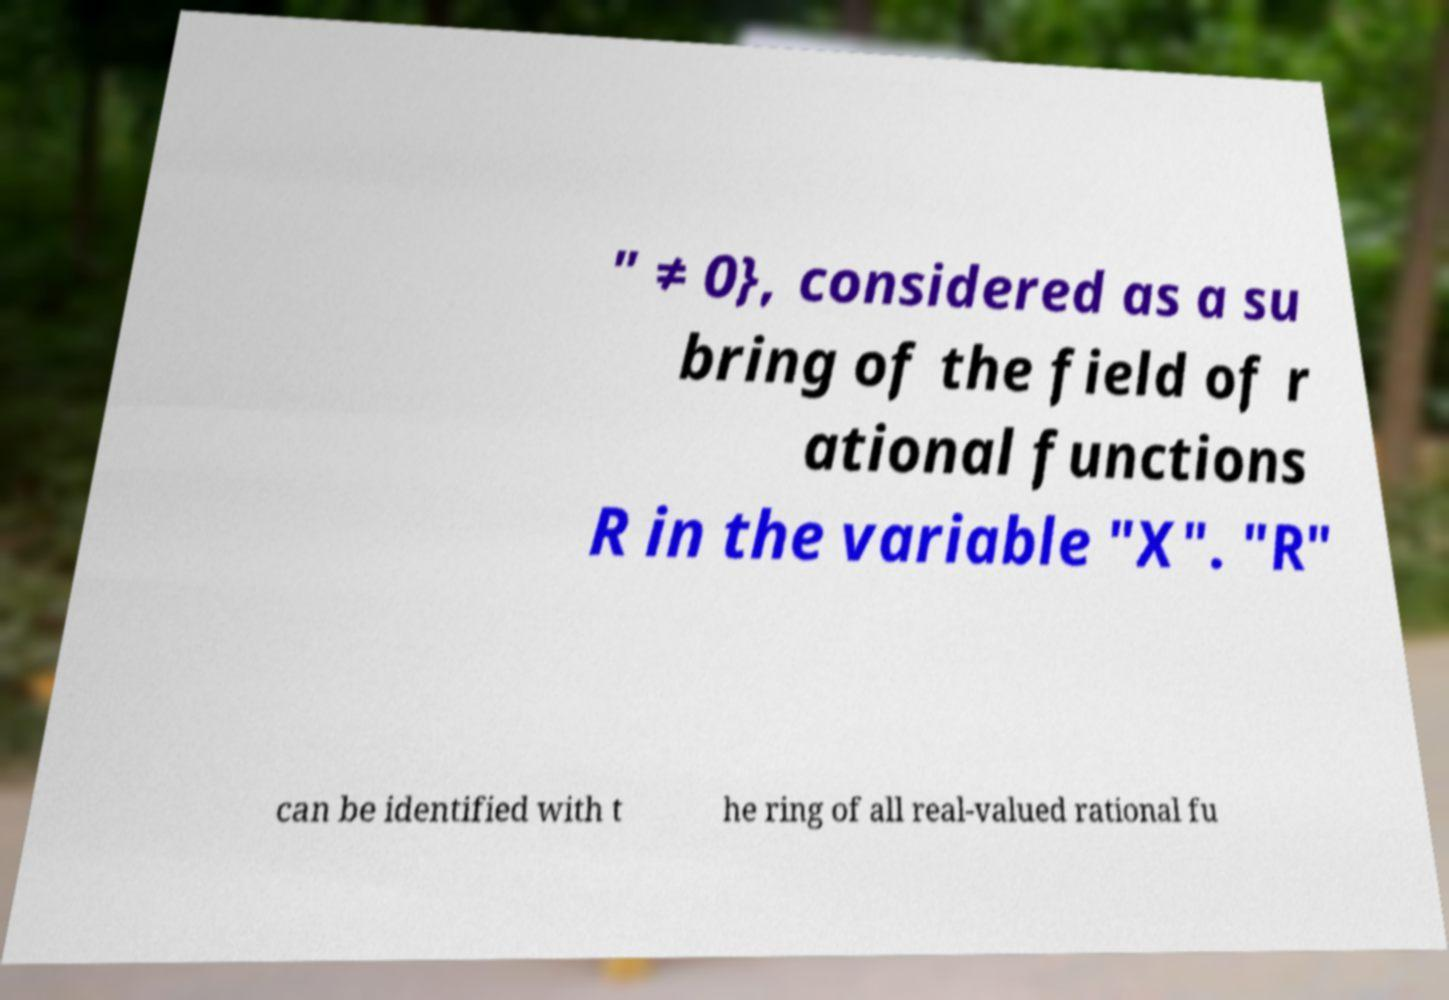Can you read and provide the text displayed in the image?This photo seems to have some interesting text. Can you extract and type it out for me? " ≠ 0}, considered as a su bring of the field of r ational functions R in the variable "X". "R" can be identified with t he ring of all real-valued rational fu 